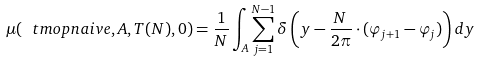<formula> <loc_0><loc_0><loc_500><loc_500>\mu ( \ t m o p { n a i v e } , A , T ( N ) , 0 ) = \frac { 1 } { N } \int _ { A } \sum _ { j = 1 } ^ { N - 1 } \delta \left ( y - \frac { N } { 2 \pi } \cdot ( \varphi _ { j + 1 } - \varphi _ { j } ) \right ) d y</formula> 